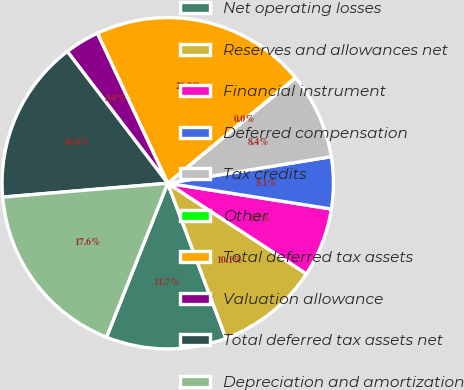Convert chart. <chart><loc_0><loc_0><loc_500><loc_500><pie_chart><fcel>Net operating losses<fcel>Reserves and allowances net<fcel>Financial instrument<fcel>Deferred compensation<fcel>Tax credits<fcel>Other<fcel>Total deferred tax assets<fcel>Valuation allowance<fcel>Total deferred tax assets net<fcel>Depreciation and amortization<nl><fcel>11.74%<fcel>10.07%<fcel>6.73%<fcel>5.05%<fcel>8.4%<fcel>0.04%<fcel>20.98%<fcel>3.38%<fcel>15.97%<fcel>17.64%<nl></chart> 